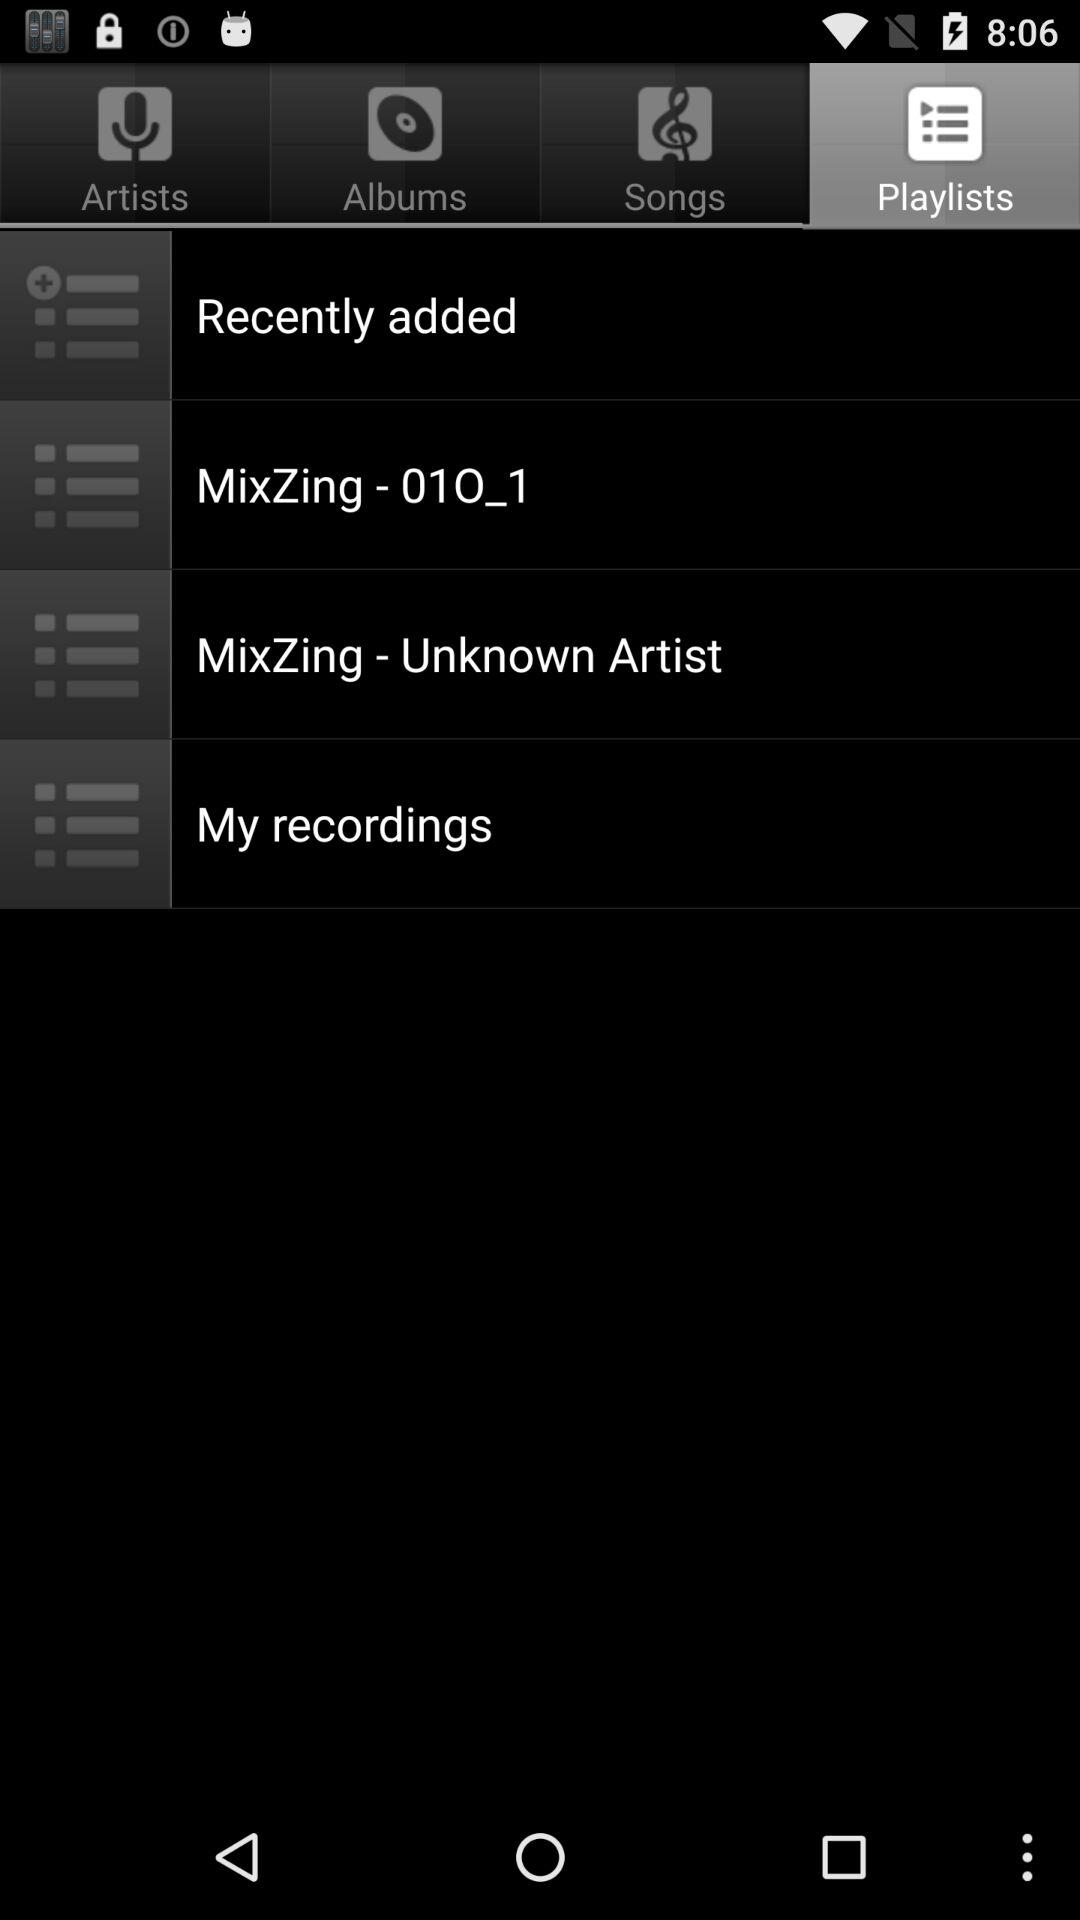Which songs are in the playlist?
When the provided information is insufficient, respond with <no answer>. <no answer> 